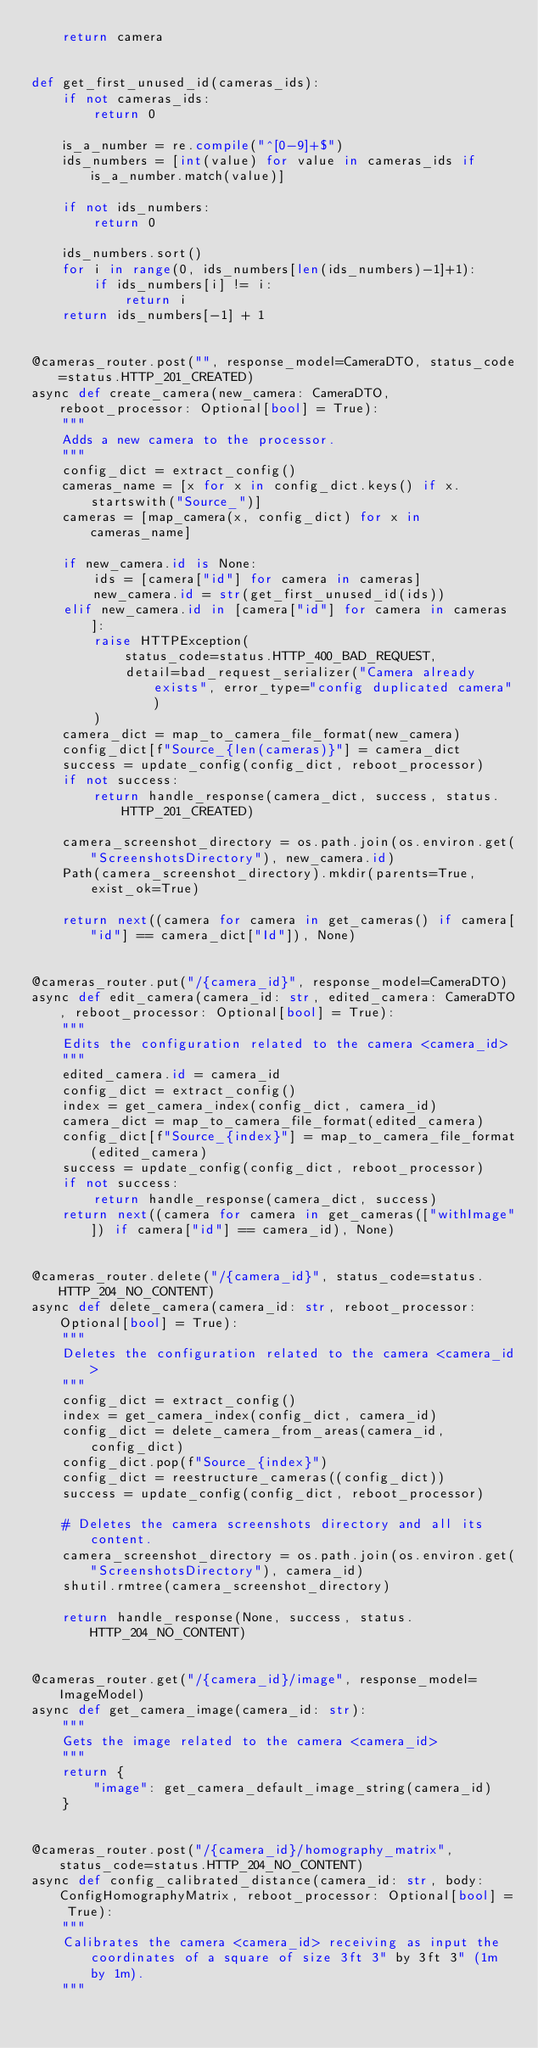<code> <loc_0><loc_0><loc_500><loc_500><_Python_>    return camera


def get_first_unused_id(cameras_ids):
    if not cameras_ids:
        return 0

    is_a_number = re.compile("^[0-9]+$")
    ids_numbers = [int(value) for value in cameras_ids if is_a_number.match(value)]

    if not ids_numbers:
        return 0

    ids_numbers.sort()
    for i in range(0, ids_numbers[len(ids_numbers)-1]+1):
        if ids_numbers[i] != i:
            return i
    return ids_numbers[-1] + 1


@cameras_router.post("", response_model=CameraDTO, status_code=status.HTTP_201_CREATED)
async def create_camera(new_camera: CameraDTO, reboot_processor: Optional[bool] = True):
    """
    Adds a new camera to the processor.
    """
    config_dict = extract_config()
    cameras_name = [x for x in config_dict.keys() if x.startswith("Source_")]
    cameras = [map_camera(x, config_dict) for x in cameras_name]

    if new_camera.id is None:
        ids = [camera["id"] for camera in cameras]
        new_camera.id = str(get_first_unused_id(ids))
    elif new_camera.id in [camera["id"] for camera in cameras]:
        raise HTTPException(
            status_code=status.HTTP_400_BAD_REQUEST,
            detail=bad_request_serializer("Camera already exists", error_type="config duplicated camera")
        )
    camera_dict = map_to_camera_file_format(new_camera)
    config_dict[f"Source_{len(cameras)}"] = camera_dict
    success = update_config(config_dict, reboot_processor)
    if not success:
        return handle_response(camera_dict, success, status.HTTP_201_CREATED)

    camera_screenshot_directory = os.path.join(os.environ.get("ScreenshotsDirectory"), new_camera.id)
    Path(camera_screenshot_directory).mkdir(parents=True, exist_ok=True)

    return next((camera for camera in get_cameras() if camera["id"] == camera_dict["Id"]), None)


@cameras_router.put("/{camera_id}", response_model=CameraDTO)
async def edit_camera(camera_id: str, edited_camera: CameraDTO, reboot_processor: Optional[bool] = True):
    """
    Edits the configuration related to the camera <camera_id>
    """
    edited_camera.id = camera_id
    config_dict = extract_config()
    index = get_camera_index(config_dict, camera_id)
    camera_dict = map_to_camera_file_format(edited_camera)
    config_dict[f"Source_{index}"] = map_to_camera_file_format(edited_camera)
    success = update_config(config_dict, reboot_processor)
    if not success:
        return handle_response(camera_dict, success)
    return next((camera for camera in get_cameras(["withImage"]) if camera["id"] == camera_id), None)


@cameras_router.delete("/{camera_id}", status_code=status.HTTP_204_NO_CONTENT)
async def delete_camera(camera_id: str, reboot_processor: Optional[bool] = True):
    """
    Deletes the configuration related to the camera <camera_id>
    """
    config_dict = extract_config()
    index = get_camera_index(config_dict, camera_id)
    config_dict = delete_camera_from_areas(camera_id, config_dict)
    config_dict.pop(f"Source_{index}")
    config_dict = reestructure_cameras((config_dict))
    success = update_config(config_dict, reboot_processor)

    # Deletes the camera screenshots directory and all its content.
    camera_screenshot_directory = os.path.join(os.environ.get("ScreenshotsDirectory"), camera_id)
    shutil.rmtree(camera_screenshot_directory)

    return handle_response(None, success, status.HTTP_204_NO_CONTENT)


@cameras_router.get("/{camera_id}/image", response_model=ImageModel)
async def get_camera_image(camera_id: str):
    """
    Gets the image related to the camera <camera_id>
    """
    return {
        "image": get_camera_default_image_string(camera_id)
    }


@cameras_router.post("/{camera_id}/homography_matrix", status_code=status.HTTP_204_NO_CONTENT)
async def config_calibrated_distance(camera_id: str, body: ConfigHomographyMatrix, reboot_processor: Optional[bool] = True):
    """
    Calibrates the camera <camera_id> receiving as input the coordinates of a square of size 3ft 3" by 3ft 3" (1m by 1m).
    """</code> 